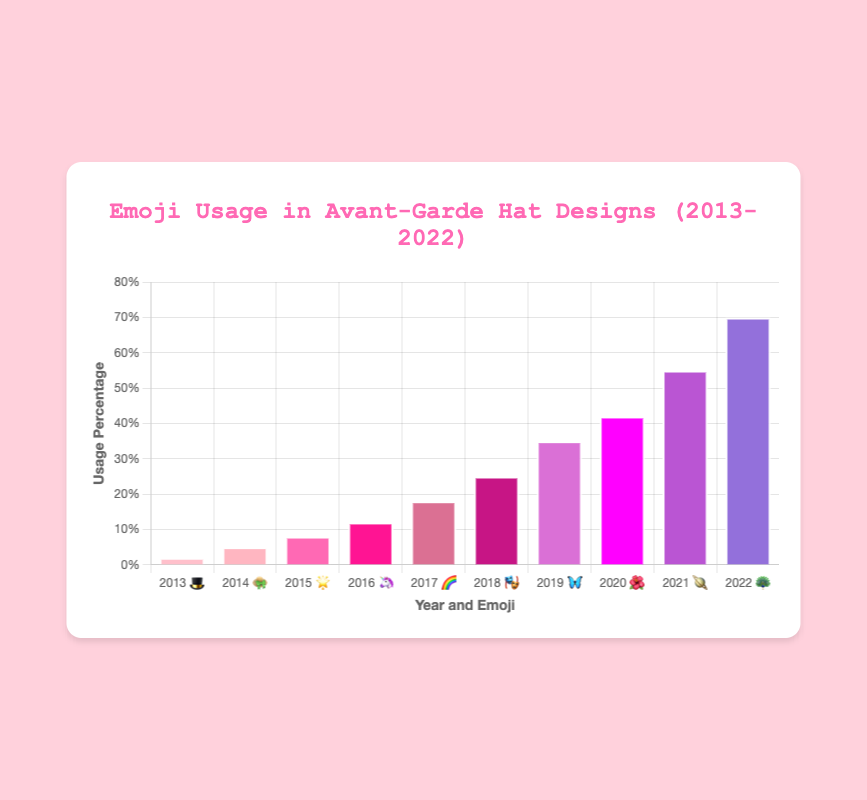What's the title of the chart? The title is displayed at the top center of the chart. It is written in larger and different colored text compared to the rest of the chart. The title reads "Emoji Usage in Avant-Garde Hat Designs (2013-2022)"
Answer: Emoji Usage in Avant-Garde Hat Designs (2013-2022) What is the emoji with the highest usage percentage in 2022? Look at the bar corresponding to the year 2022 on the x-axis. The label for this bar includes the emoji 🦚 , and the corresponding data point shows a usage percentage of 70%.
Answer: 🦚 Which year had a higher usage percentage of the 🌈 emoji: 2016 or 2017? Compare the values for the years 2016 and 2017. The year 2016 has a usage percentage of 12% for the 🦄 emoji, while 2017 has 18% for the 🌈 emoji.
Answer: 2017 How much did the usage percentage increase from 2019 to 2020? To find the increase, subtract the 2019 percentage from the 2020 percentage. In 2019, the 🦋 emoji usage was 35%, and in 2020, the 🌺 emoji usage was 42%. So, 42% - 35% = 7%.
Answer: 7% What's the average emoji usage percentage between 2013 and 2017? Find the usage percentages for the years 2013, 2014, 2015, 2016, and 2017 and calculate their average. The values are 2%, 5%, 8%, 12%, and 18%. Sum: 2 + 5 + 8 + 12 + 18 = 45. Average: 45 / 5 = 9%.
Answer: 9% Which emoji showed a significant increase in usage between 2021 and 2022? Compare the usage percentages between 2021 and 2022. In 2021, the 🪐 emoji was used 55%, and in 2022, the 🦚 emoji usage increased to 70%, which is a significant increase.
Answer: 🦚 What is the color of the bar representing the year 2018? Identify the bar corresponding to the year 2018 and note its color. The bar for 2018 is pink, specifically a magenta shade.
Answer: Magenta How many total data points are represented in the chart? Count the distinct years represented on the x-axis from 2013 to 2022; each year is a data point, giving a total of 10 data points.
Answer: 10 Between which consecutive years is the largest increase in emoji usage percentage observed? Calculate the percentage increase between each pair of consecutive years and find the largest. The largest increase is between 2021 (55%) and 2022 (70%).
Answer: 2021 to 2022 